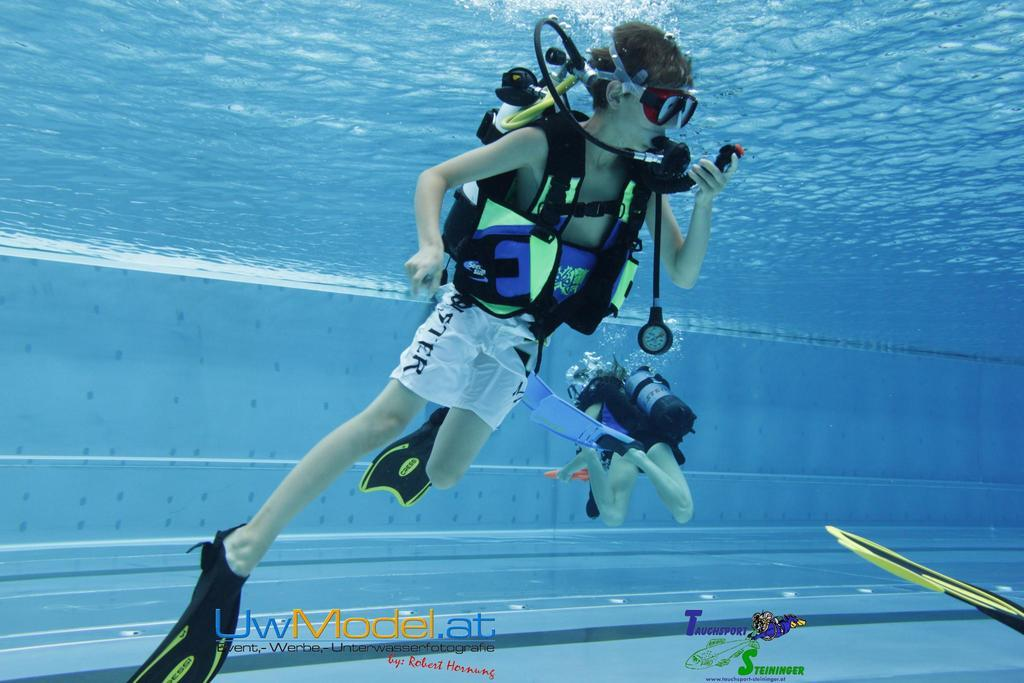What is the primary element visible in the image? There is water in the image. Are there any people in the image? Yes, there are people in the image. What equipment is being used by the people in the image? A buoyancy compensator is present in the image. How many patches can be seen on the club in the image? There is no club present in the image, and therefore no patches can be seen. 